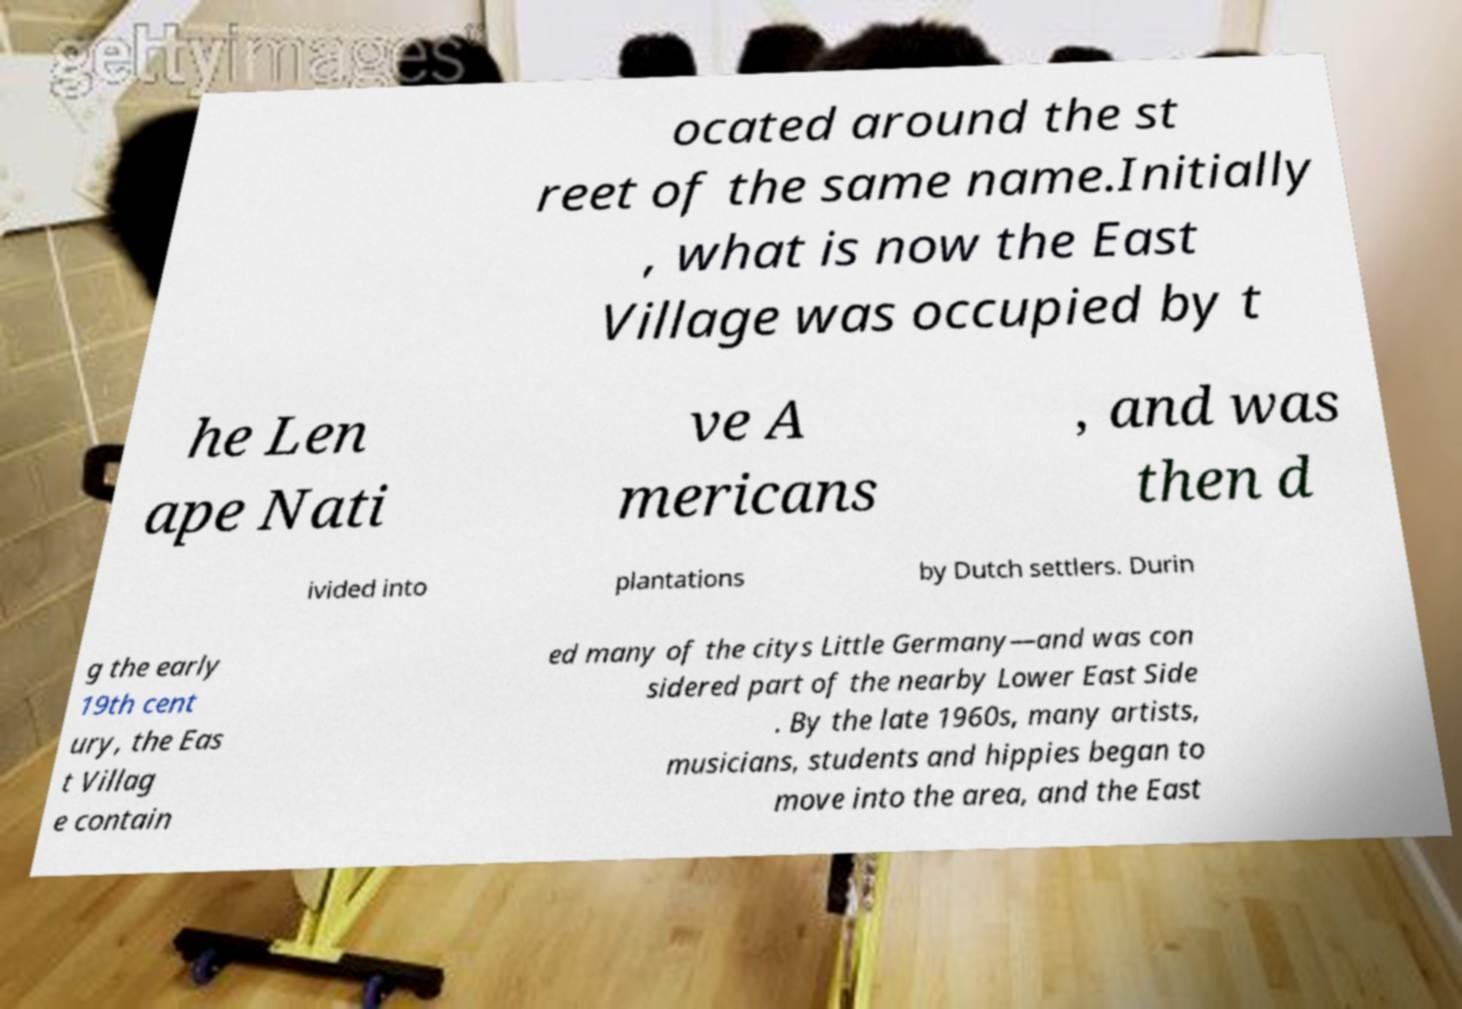Can you read and provide the text displayed in the image?This photo seems to have some interesting text. Can you extract and type it out for me? ocated around the st reet of the same name.Initially , what is now the East Village was occupied by t he Len ape Nati ve A mericans , and was then d ivided into plantations by Dutch settlers. Durin g the early 19th cent ury, the Eas t Villag e contain ed many of the citys Little Germany—and was con sidered part of the nearby Lower East Side . By the late 1960s, many artists, musicians, students and hippies began to move into the area, and the East 